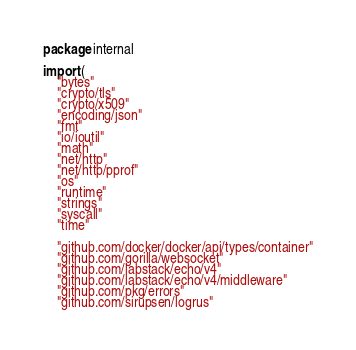Convert code to text. <code><loc_0><loc_0><loc_500><loc_500><_Go_>package internal

import (
	"bytes"
	"crypto/tls"
	"crypto/x509"
	"encoding/json"
	"fmt"
	"io/ioutil"
	"math"
	"net/http"
	"net/http/pprof"
	"os"
	"runtime"
	"strings"
	"syscall"
	"time"

	"github.com/docker/docker/api/types/container"
	"github.com/gorilla/websocket"
	"github.com/labstack/echo/v4"
	"github.com/labstack/echo/v4/middleware"
	"github.com/pkg/errors"
	"github.com/sirupsen/logrus"
</code> 